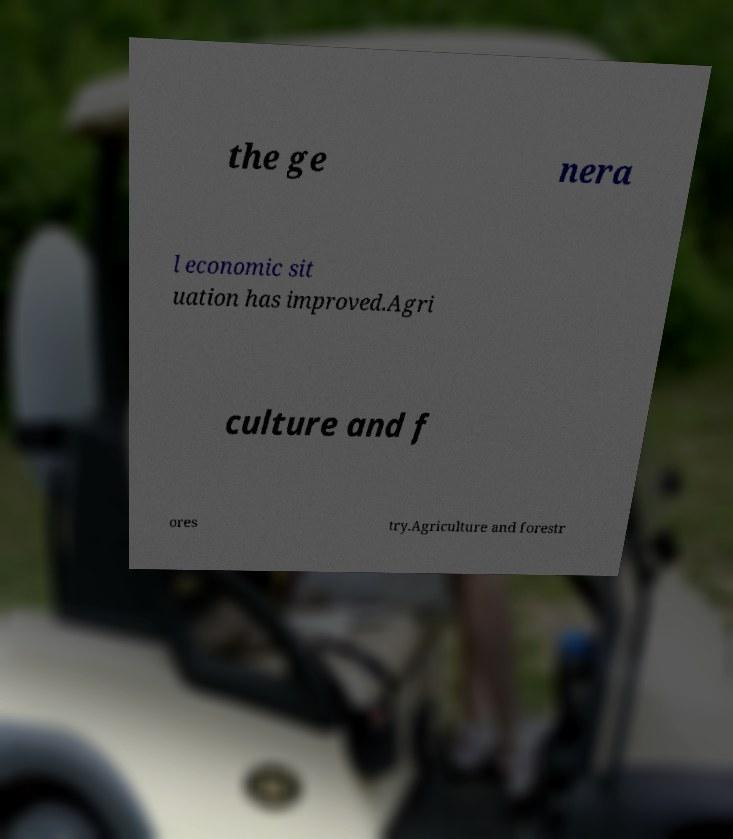Please read and relay the text visible in this image. What does it say? the ge nera l economic sit uation has improved.Agri culture and f ores try.Agriculture and forestr 